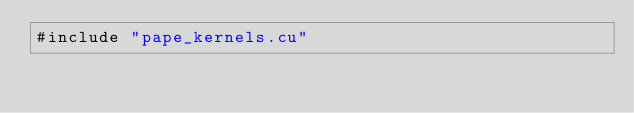Convert code to text. <code><loc_0><loc_0><loc_500><loc_500><_Cuda_>#include "pape_kernels.cu"

</code> 